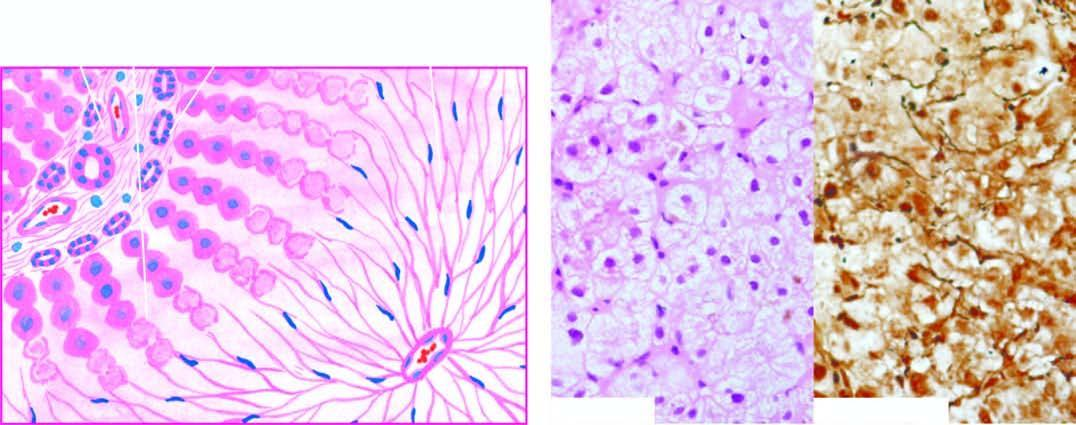where is there?
Answer the question using a single word or phrase. No significant inflammation or fibrosis 